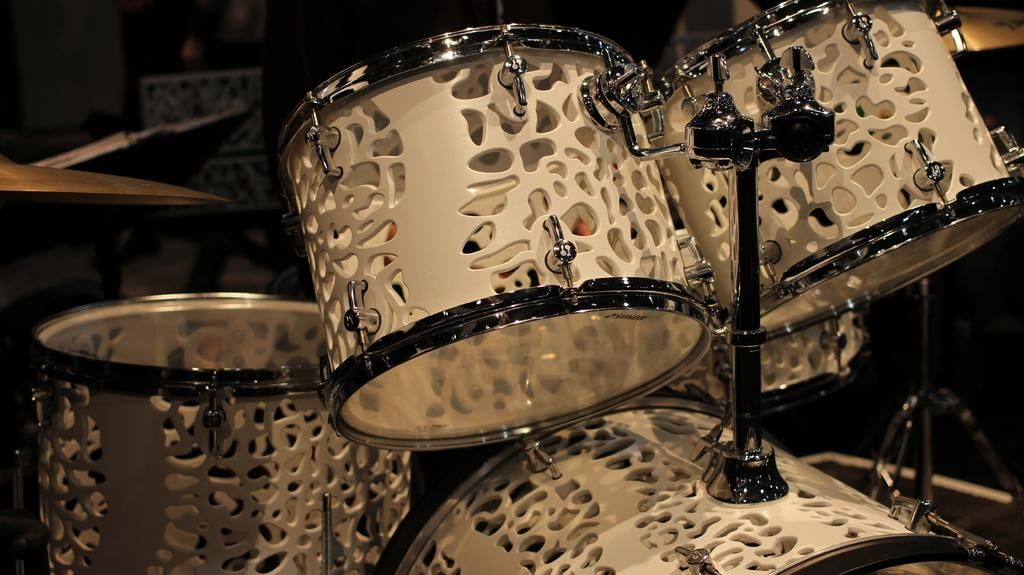What type of musical instrument is present in the image? There are musical drums in the image. What other objects can be seen in the image besides the drums? There are rods and other objects in the image. Can you describe the background of the image? The background of the image is blurry. What type of fruit is being measured in the image? There is no fruit or measuring activity present in the image. 